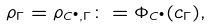Convert formula to latex. <formula><loc_0><loc_0><loc_500><loc_500>\rho _ { \Gamma } = \rho _ { C ^ { \bullet } , \Gamma } \colon = \Phi _ { C ^ { \bullet } } ( c _ { \Gamma } ) ,</formula> 